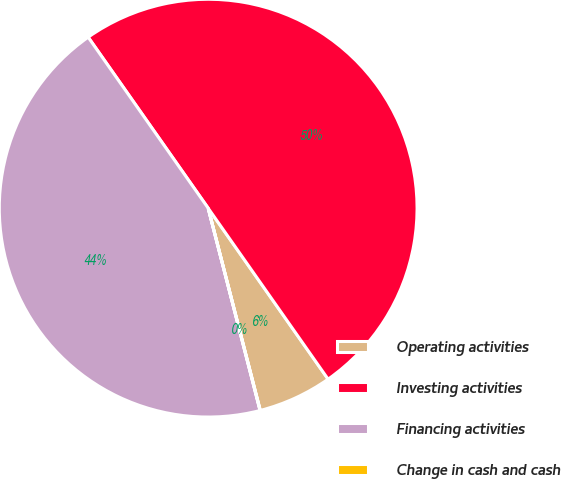Convert chart. <chart><loc_0><loc_0><loc_500><loc_500><pie_chart><fcel>Operating activities<fcel>Investing activities<fcel>Financing activities<fcel>Change in cash and cash<nl><fcel>5.72%<fcel>50.0%<fcel>44.25%<fcel>0.02%<nl></chart> 